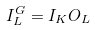Convert formula to latex. <formula><loc_0><loc_0><loc_500><loc_500>I _ { L } ^ { G } = I _ { K } O _ { L }</formula> 